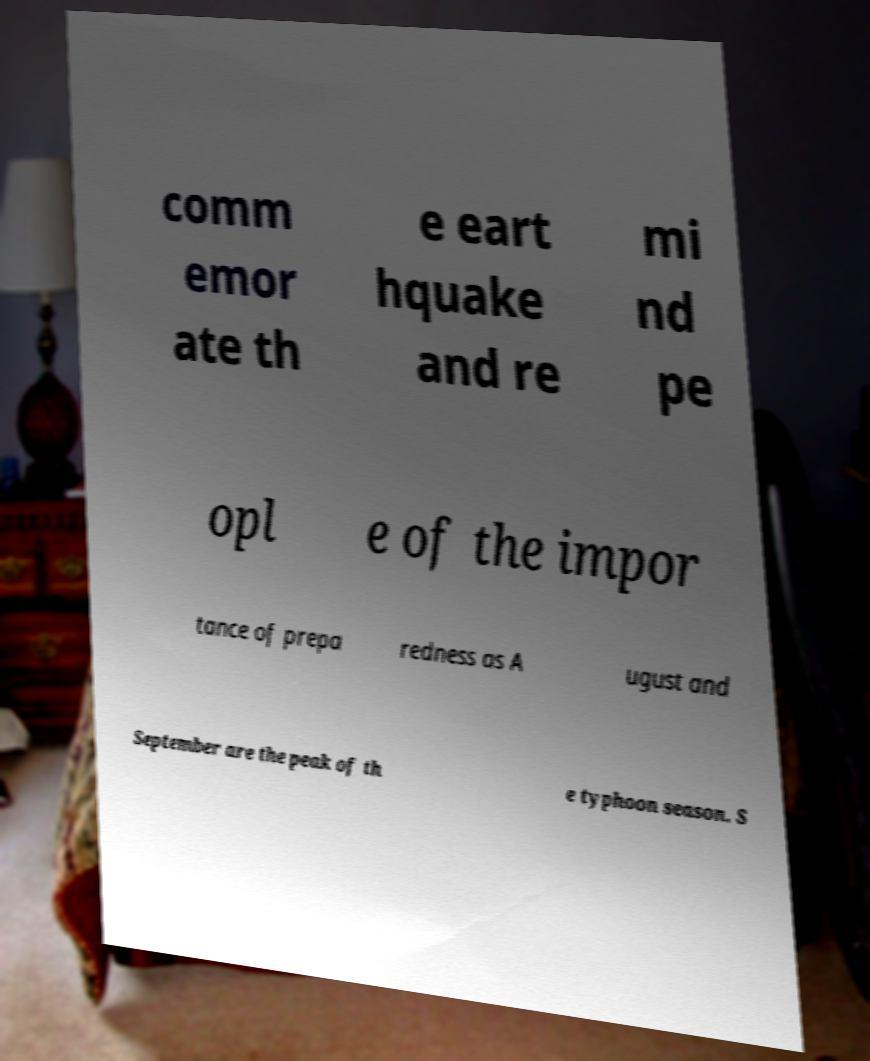Can you read and provide the text displayed in the image?This photo seems to have some interesting text. Can you extract and type it out for me? comm emor ate th e eart hquake and re mi nd pe opl e of the impor tance of prepa redness as A ugust and September are the peak of th e typhoon season. S 